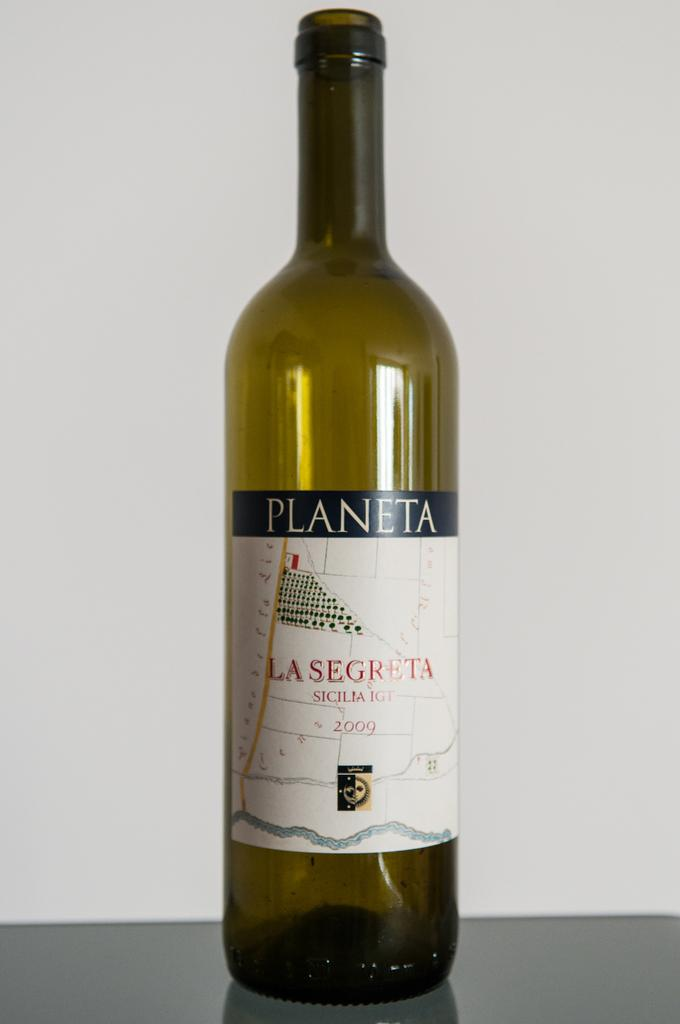<image>
Render a clear and concise summary of the photo. a bottle that has the word planeta on it 